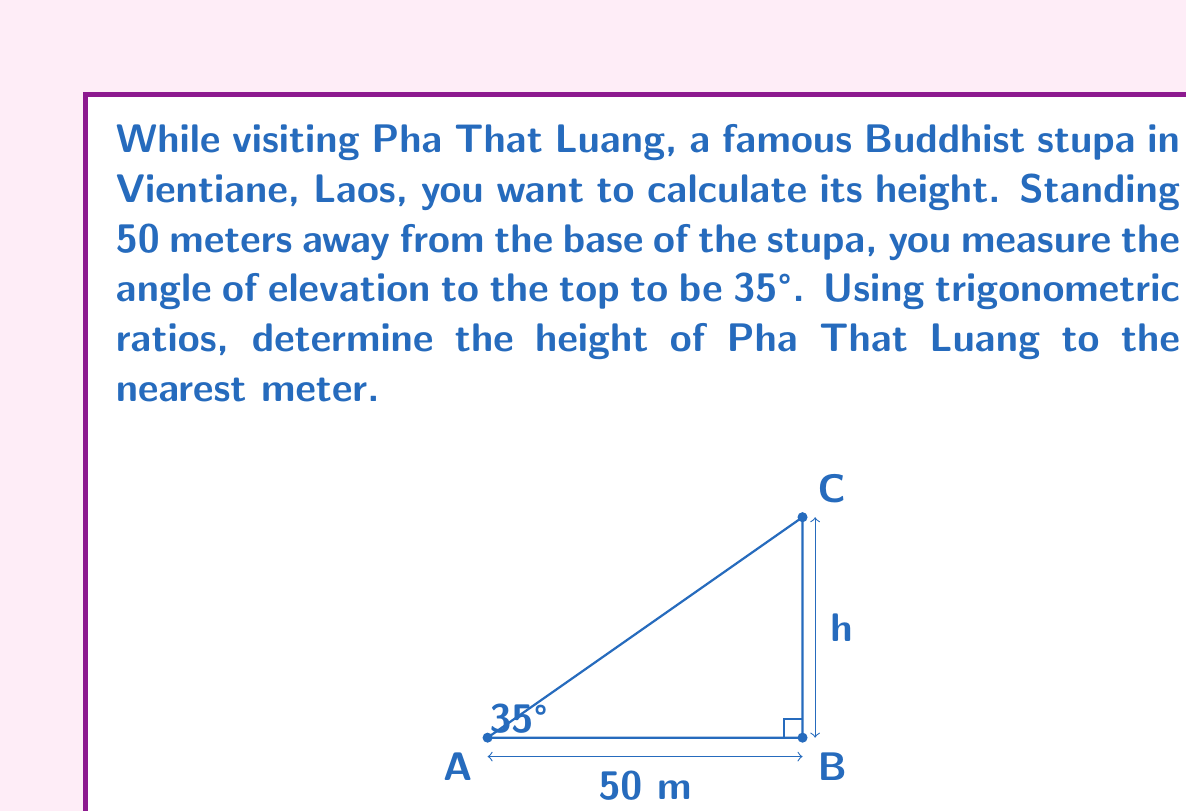Help me with this question. Let's approach this step-by-step:

1) In this problem, we have a right triangle where:
   - The adjacent side is the distance from you to the base of the stupa (50 meters)
   - The opposite side is the height of the stupa (h)
   - The angle of elevation is 35°

2) We need to use the tangent ratio, as we're relating the opposite side to the adjacent side:

   $$\tan(\theta) = \frac{\text{opposite}}{\text{adjacent}}$$

3) Plugging in our known values:

   $$\tan(35°) = \frac{h}{50}$$

4) To solve for h, we multiply both sides by 50:

   $$50 \cdot \tan(35°) = h$$

5) Now we can calculate:
   
   $$h = 50 \cdot \tan(35°)$$
   $$h = 50 \cdot 0.7002$$
   $$h = 35.01\text{ meters}$$

6) Rounding to the nearest meter:

   $$h \approx 35\text{ meters}$$

Thus, the height of Pha That Luang is approximately 35 meters.
Answer: 35 meters 